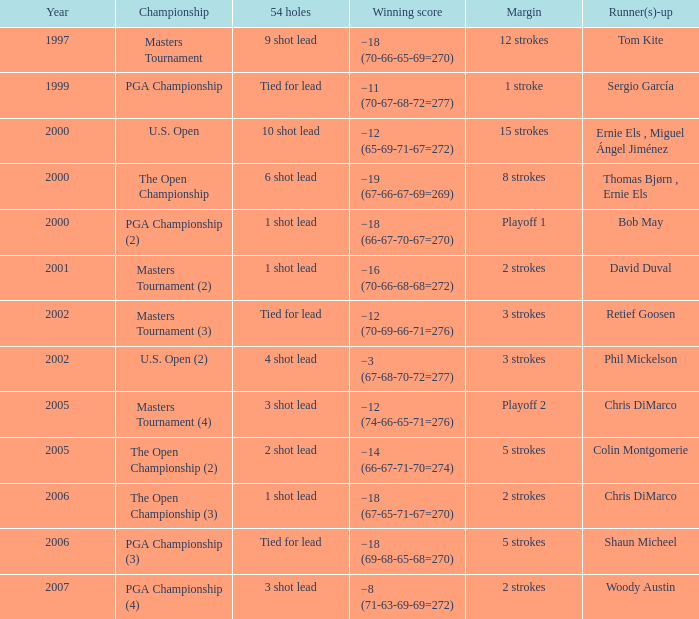 what's the margin where runner(s)-up is phil mickelson 3 strokes. Could you help me parse every detail presented in this table? {'header': ['Year', 'Championship', '54 holes', 'Winning score', 'Margin', 'Runner(s)-up'], 'rows': [['1997', 'Masters Tournament', '9 shot lead', '−18 (70-66-65-69=270)', '12 strokes', 'Tom Kite'], ['1999', 'PGA Championship', 'Tied for lead', '−11 (70-67-68-72=277)', '1 stroke', 'Sergio García'], ['2000', 'U.S. Open', '10 shot lead', '−12 (65-69-71-67=272)', '15 strokes', 'Ernie Els , Miguel Ángel Jiménez'], ['2000', 'The Open Championship', '6 shot lead', '−19 (67-66-67-69=269)', '8 strokes', 'Thomas Bjørn , Ernie Els'], ['2000', 'PGA Championship (2)', '1 shot lead', '−18 (66-67-70-67=270)', 'Playoff 1', 'Bob May'], ['2001', 'Masters Tournament (2)', '1 shot lead', '−16 (70-66-68-68=272)', '2 strokes', 'David Duval'], ['2002', 'Masters Tournament (3)', 'Tied for lead', '−12 (70-69-66-71=276)', '3 strokes', 'Retief Goosen'], ['2002', 'U.S. Open (2)', '4 shot lead', '−3 (67-68-70-72=277)', '3 strokes', 'Phil Mickelson'], ['2005', 'Masters Tournament (4)', '3 shot lead', '−12 (74-66-65-71=276)', 'Playoff 2', 'Chris DiMarco'], ['2005', 'The Open Championship (2)', '2 shot lead', '−14 (66-67-71-70=274)', '5 strokes', 'Colin Montgomerie'], ['2006', 'The Open Championship (3)', '1 shot lead', '−18 (67-65-71-67=270)', '2 strokes', 'Chris DiMarco'], ['2006', 'PGA Championship (3)', 'Tied for lead', '−18 (69-68-65-68=270)', '5 strokes', 'Shaun Micheel'], ['2007', 'PGA Championship (4)', '3 shot lead', '−8 (71-63-69-69=272)', '2 strokes', 'Woody Austin']]} 